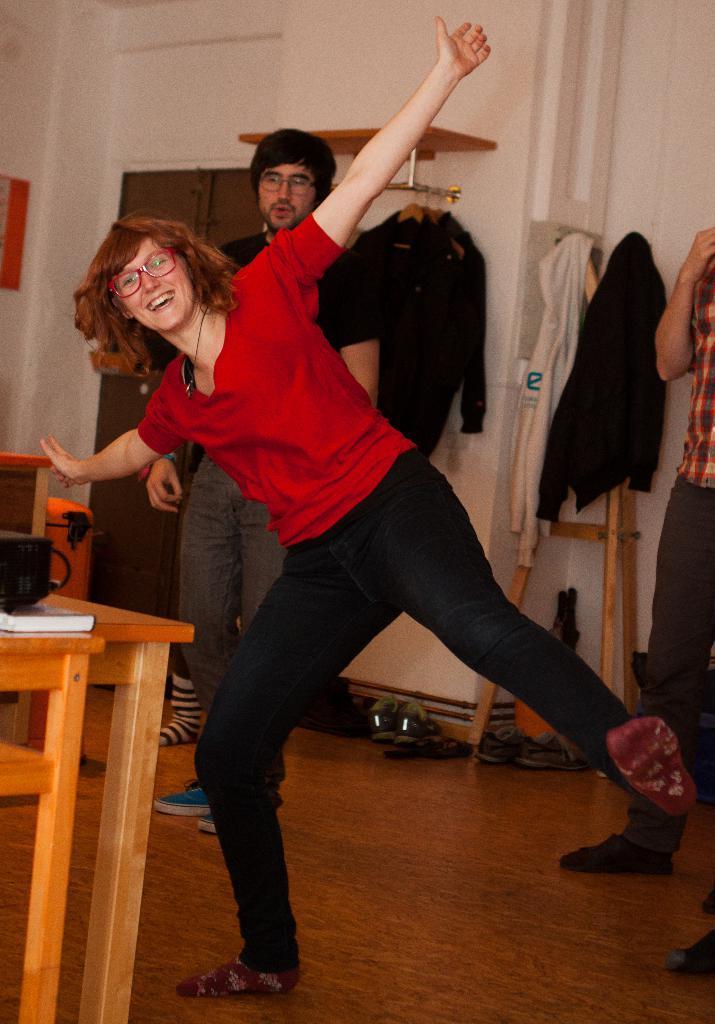Describe this image in one or two sentences. This picture is clicked inside the room. The girl in red shirt and black pant is standing. She is wearing spectacles and she is smiling. I think she is dancing. Behind her, the man in black T-shirt is standing. Behind him, we see shirts are hanged to the hangers. Behind that, we see a white wall. On the left side, we see a table on which cup is placed. Behind that, we see a wall on which photo frame is placed. The man in red check shirt is standing. 